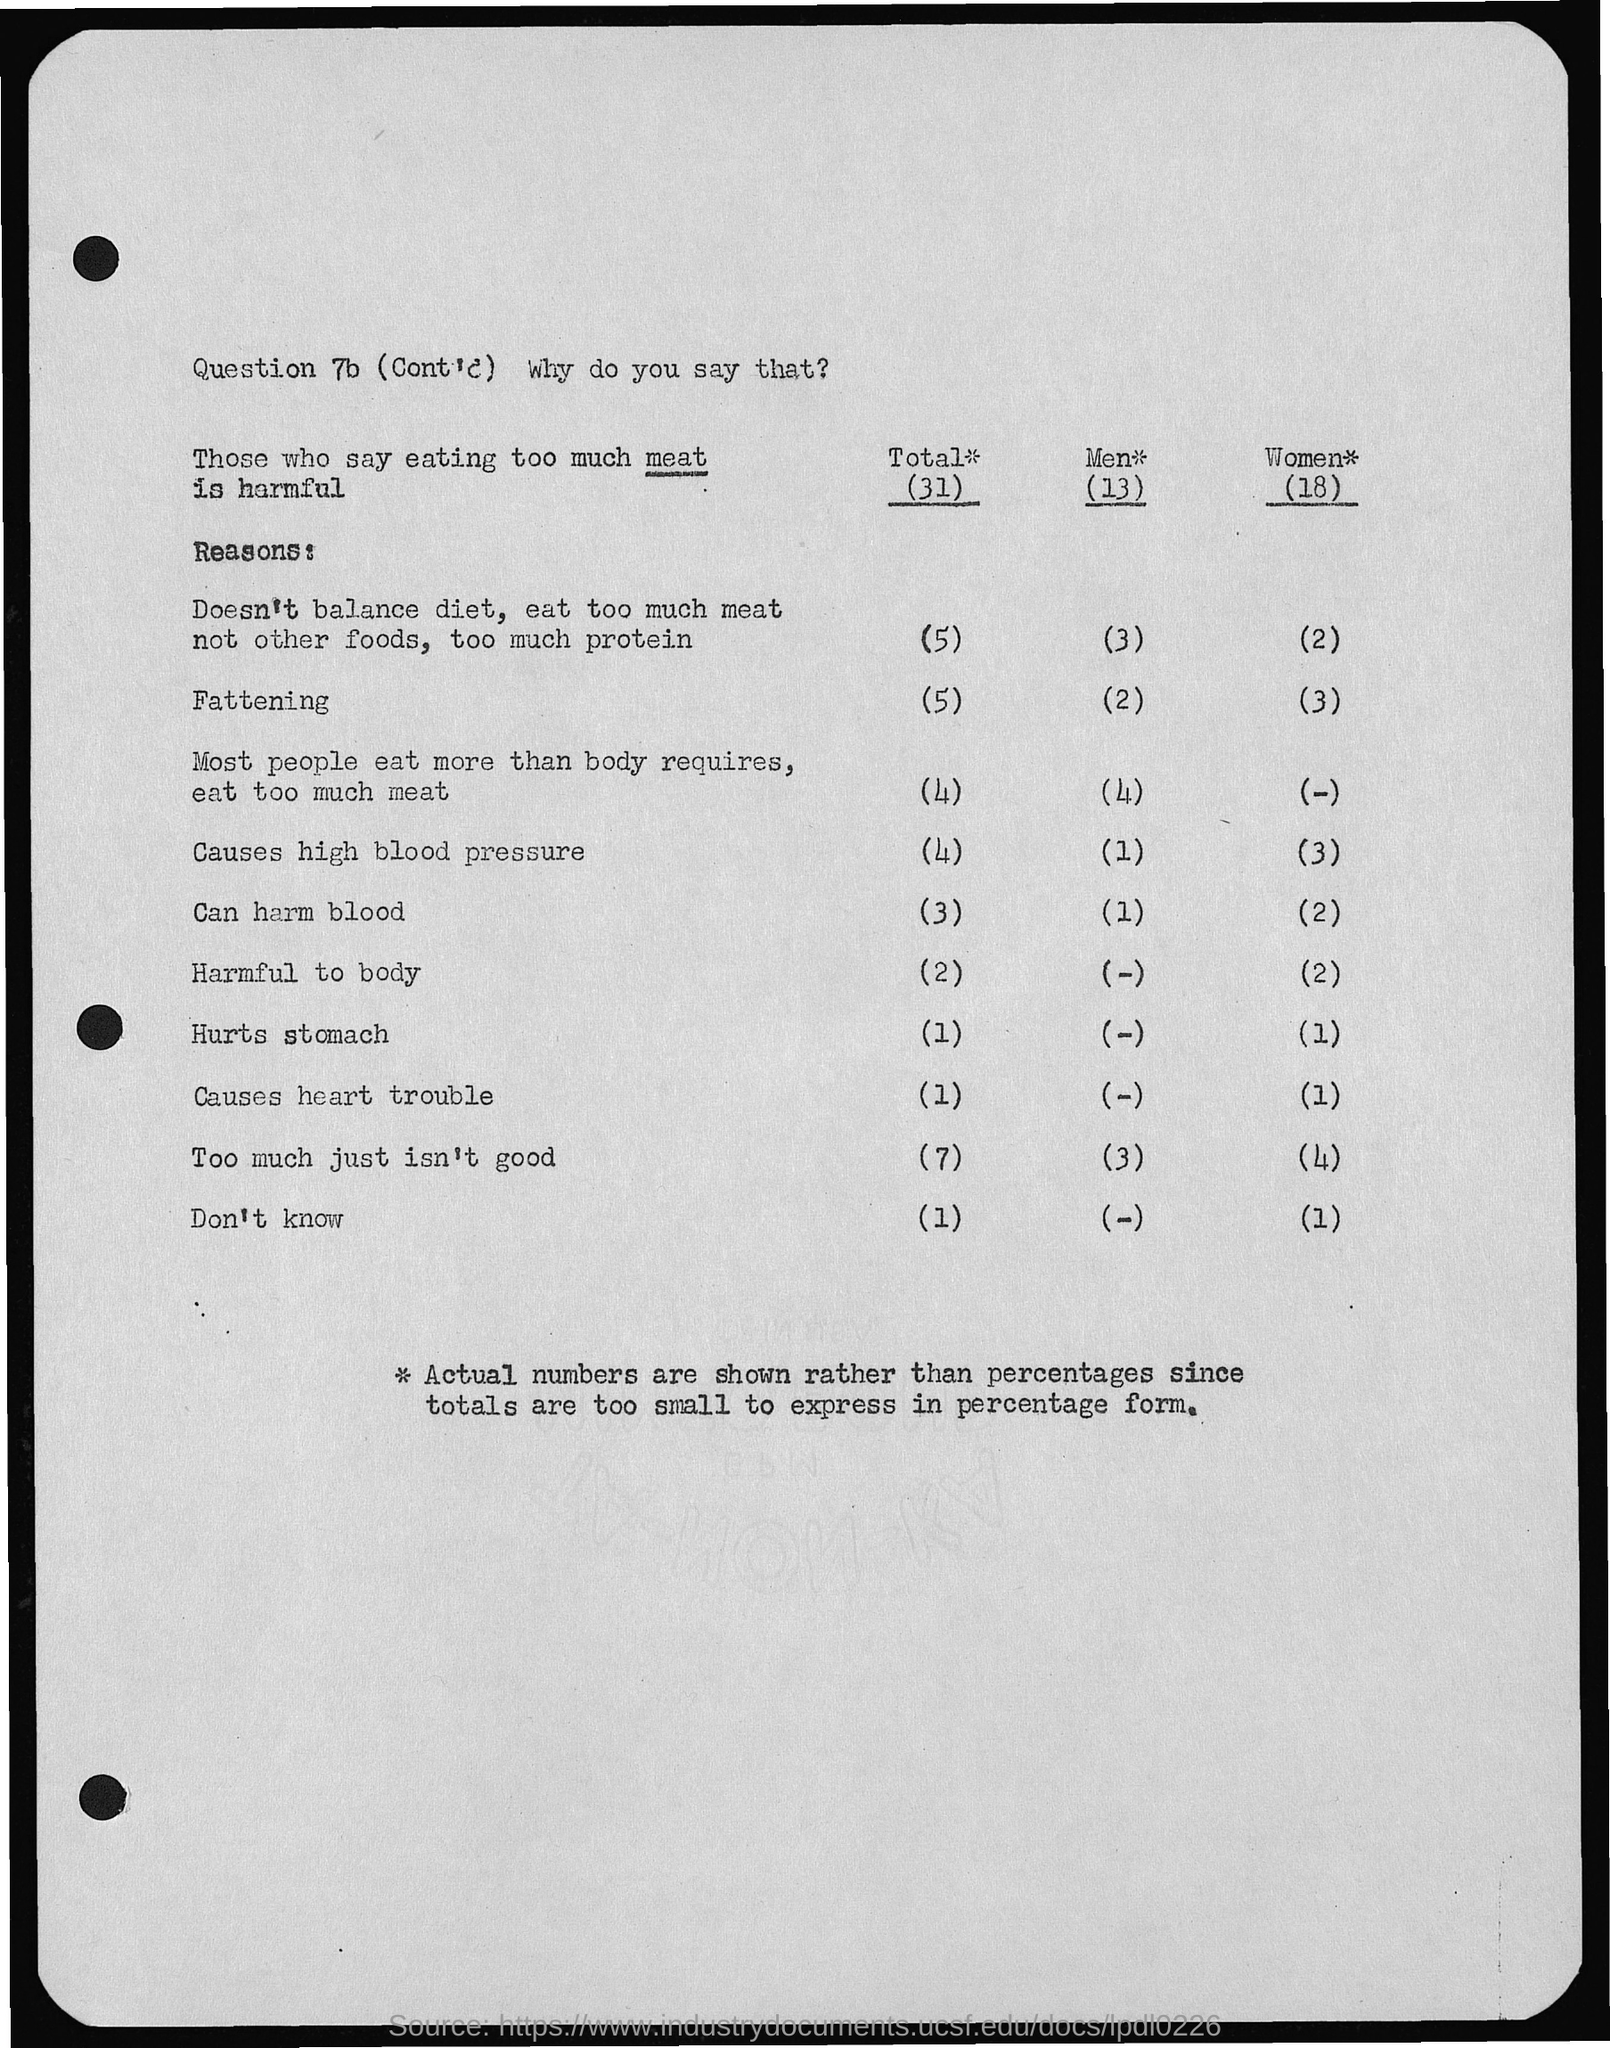How many women say eating too much meat is harmful?
Offer a very short reply. 18. How many men say eating too much meat is harmful?
Your answer should be compact. (13). How many people in total say eating too much meat is harmful?
Your answer should be compact. 31. How many men get fattened due to eating of meat ?
Keep it short and to the point. (2). How many women get fattened due to eating of meat ?
Your answer should be compact. 3. How many people doesn't follow balance diet and eat too much meat ?
Provide a short and direct response. 5. How many men doesn't follow balance diet and eat too much meat ?
Make the answer very short. (3). 